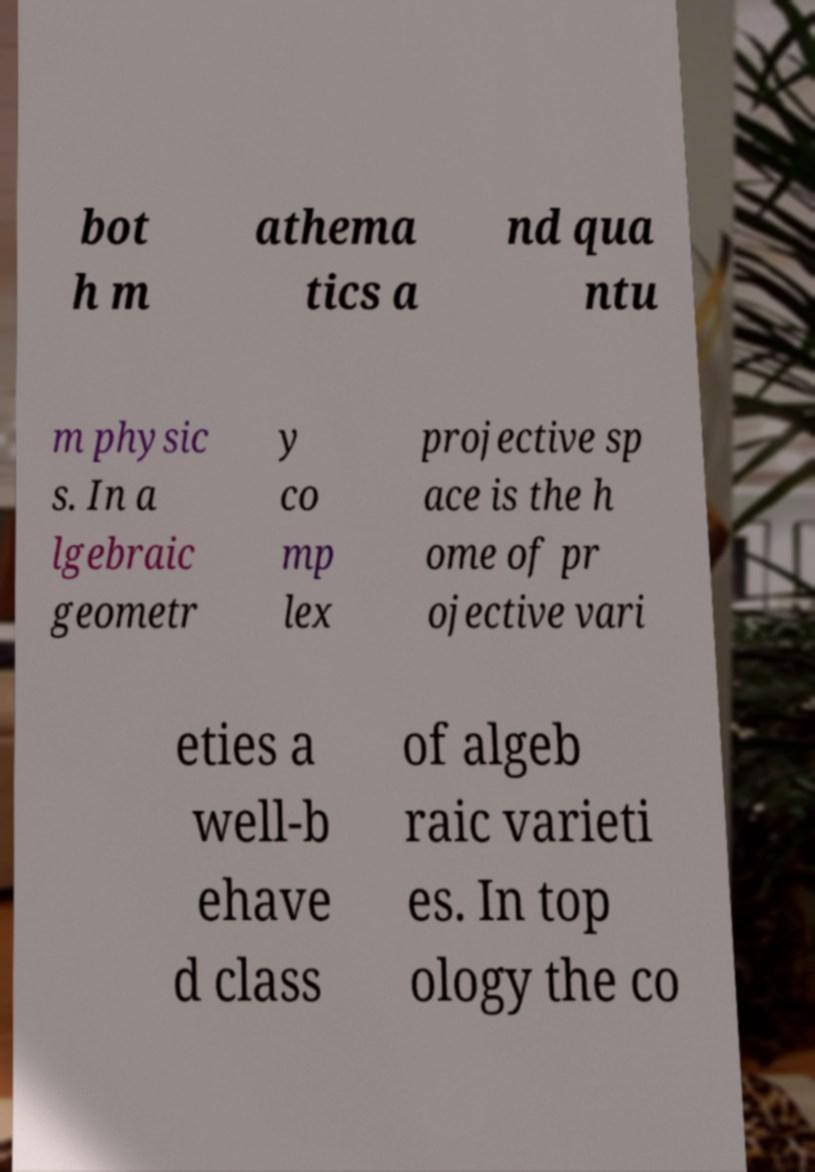There's text embedded in this image that I need extracted. Can you transcribe it verbatim? bot h m athema tics a nd qua ntu m physic s. In a lgebraic geometr y co mp lex projective sp ace is the h ome of pr ojective vari eties a well-b ehave d class of algeb raic varieti es. In top ology the co 